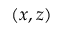<formula> <loc_0><loc_0><loc_500><loc_500>( x , z )</formula> 